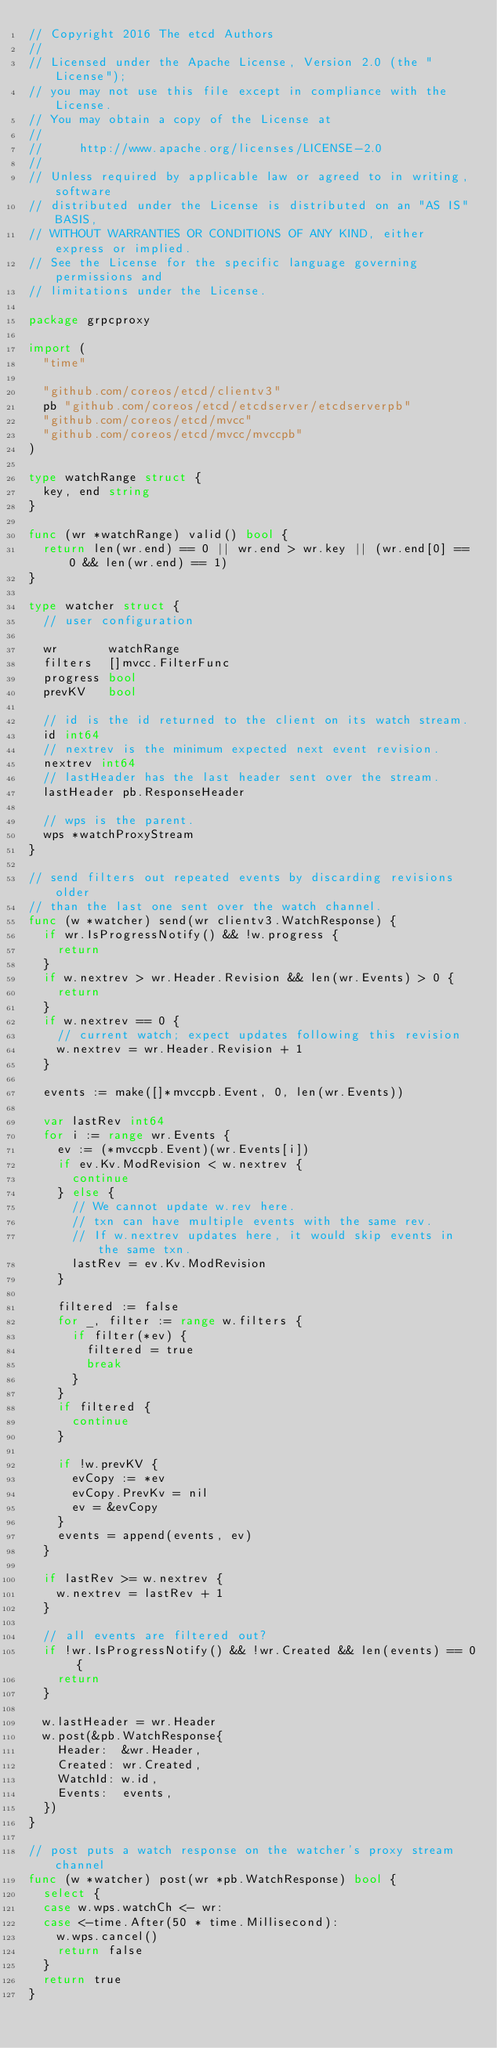<code> <loc_0><loc_0><loc_500><loc_500><_Go_>// Copyright 2016 The etcd Authors
//
// Licensed under the Apache License, Version 2.0 (the "License");
// you may not use this file except in compliance with the License.
// You may obtain a copy of the License at
//
//     http://www.apache.org/licenses/LICENSE-2.0
//
// Unless required by applicable law or agreed to in writing, software
// distributed under the License is distributed on an "AS IS" BASIS,
// WITHOUT WARRANTIES OR CONDITIONS OF ANY KIND, either express or implied.
// See the License for the specific language governing permissions and
// limitations under the License.

package grpcproxy

import (
	"time"

	"github.com/coreos/etcd/clientv3"
	pb "github.com/coreos/etcd/etcdserver/etcdserverpb"
	"github.com/coreos/etcd/mvcc"
	"github.com/coreos/etcd/mvcc/mvccpb"
)

type watchRange struct {
	key, end string
}

func (wr *watchRange) valid() bool {
	return len(wr.end) == 0 || wr.end > wr.key || (wr.end[0] == 0 && len(wr.end) == 1)
}

type watcher struct {
	// user configuration

	wr       watchRange
	filters  []mvcc.FilterFunc
	progress bool
	prevKV   bool

	// id is the id returned to the client on its watch stream.
	id int64
	// nextrev is the minimum expected next event revision.
	nextrev int64
	// lastHeader has the last header sent over the stream.
	lastHeader pb.ResponseHeader

	// wps is the parent.
	wps *watchProxyStream
}

// send filters out repeated events by discarding revisions older
// than the last one sent over the watch channel.
func (w *watcher) send(wr clientv3.WatchResponse) {
	if wr.IsProgressNotify() && !w.progress {
		return
	}
	if w.nextrev > wr.Header.Revision && len(wr.Events) > 0 {
		return
	}
	if w.nextrev == 0 {
		// current watch; expect updates following this revision
		w.nextrev = wr.Header.Revision + 1
	}

	events := make([]*mvccpb.Event, 0, len(wr.Events))

	var lastRev int64
	for i := range wr.Events {
		ev := (*mvccpb.Event)(wr.Events[i])
		if ev.Kv.ModRevision < w.nextrev {
			continue
		} else {
			// We cannot update w.rev here.
			// txn can have multiple events with the same rev.
			// If w.nextrev updates here, it would skip events in the same txn.
			lastRev = ev.Kv.ModRevision
		}

		filtered := false
		for _, filter := range w.filters {
			if filter(*ev) {
				filtered = true
				break
			}
		}
		if filtered {
			continue
		}

		if !w.prevKV {
			evCopy := *ev
			evCopy.PrevKv = nil
			ev = &evCopy
		}
		events = append(events, ev)
	}

	if lastRev >= w.nextrev {
		w.nextrev = lastRev + 1
	}

	// all events are filtered out?
	if !wr.IsProgressNotify() && !wr.Created && len(events) == 0 {
		return
	}

	w.lastHeader = wr.Header
	w.post(&pb.WatchResponse{
		Header:  &wr.Header,
		Created: wr.Created,
		WatchId: w.id,
		Events:  events,
	})
}

// post puts a watch response on the watcher's proxy stream channel
func (w *watcher) post(wr *pb.WatchResponse) bool {
	select {
	case w.wps.watchCh <- wr:
	case <-time.After(50 * time.Millisecond):
		w.wps.cancel()
		return false
	}
	return true
}
</code> 